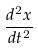<formula> <loc_0><loc_0><loc_500><loc_500>\frac { d ^ { 2 } x } { d t ^ { 2 } }</formula> 